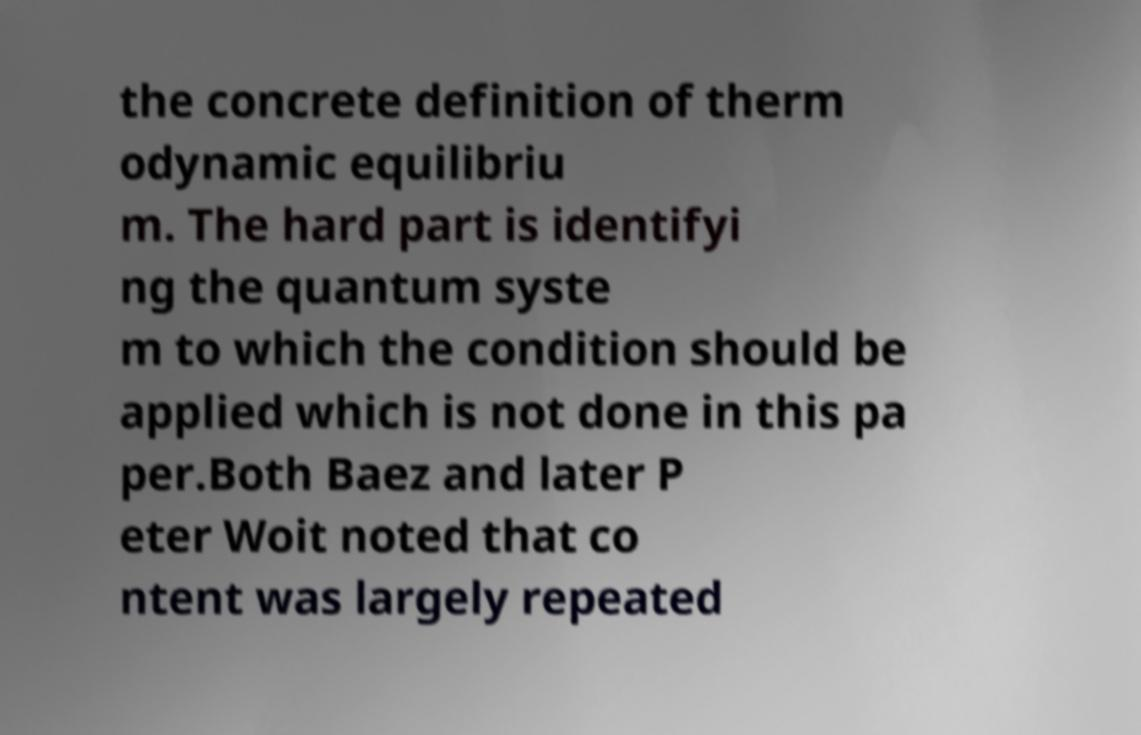What messages or text are displayed in this image? I need them in a readable, typed format. the concrete definition of therm odynamic equilibriu m. The hard part is identifyi ng the quantum syste m to which the condition should be applied which is not done in this pa per.Both Baez and later P eter Woit noted that co ntent was largely repeated 